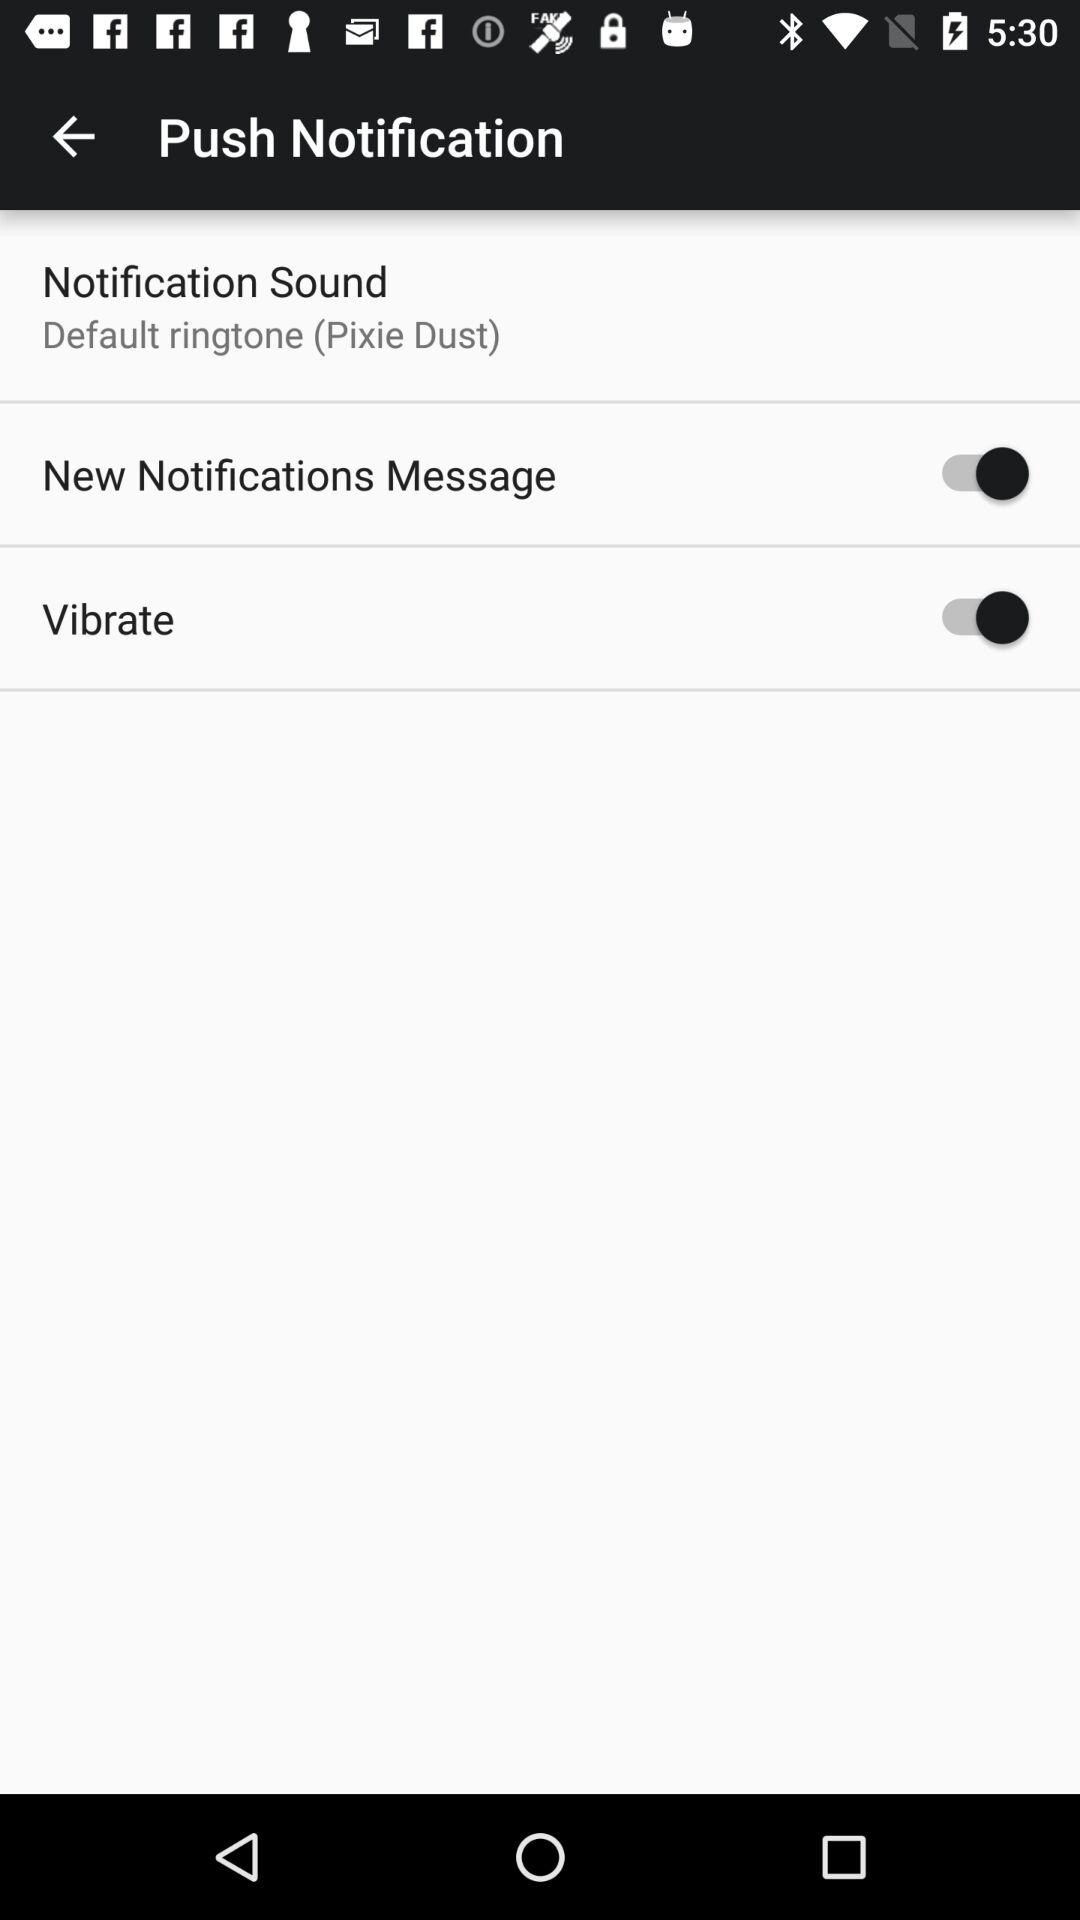What's the status of "Vibrate"? The status is on. 